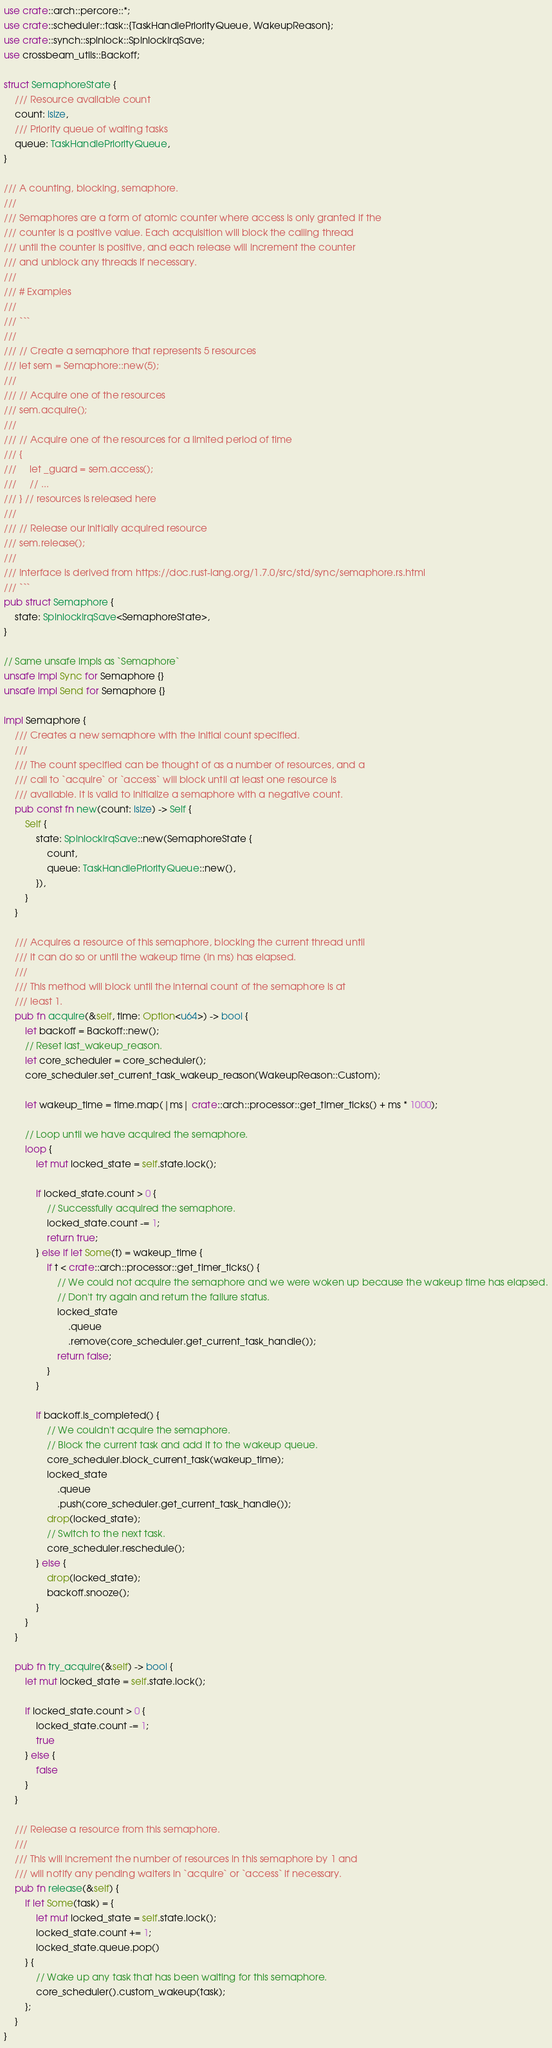<code> <loc_0><loc_0><loc_500><loc_500><_Rust_>use crate::arch::percore::*;
use crate::scheduler::task::{TaskHandlePriorityQueue, WakeupReason};
use crate::synch::spinlock::SpinlockIrqSave;
use crossbeam_utils::Backoff;

struct SemaphoreState {
	/// Resource available count
	count: isize,
	/// Priority queue of waiting tasks
	queue: TaskHandlePriorityQueue,
}

/// A counting, blocking, semaphore.
///
/// Semaphores are a form of atomic counter where access is only granted if the
/// counter is a positive value. Each acquisition will block the calling thread
/// until the counter is positive, and each release will increment the counter
/// and unblock any threads if necessary.
///
/// # Examples
///
/// ```
///
/// // Create a semaphore that represents 5 resources
/// let sem = Semaphore::new(5);
///
/// // Acquire one of the resources
/// sem.acquire();
///
/// // Acquire one of the resources for a limited period of time
/// {
///     let _guard = sem.access();
///     // ...
/// } // resources is released here
///
/// // Release our initially acquired resource
/// sem.release();
///
/// Interface is derived from https://doc.rust-lang.org/1.7.0/src/std/sync/semaphore.rs.html
/// ```
pub struct Semaphore {
	state: SpinlockIrqSave<SemaphoreState>,
}

// Same unsafe impls as `Semaphore`
unsafe impl Sync for Semaphore {}
unsafe impl Send for Semaphore {}

impl Semaphore {
	/// Creates a new semaphore with the initial count specified.
	///
	/// The count specified can be thought of as a number of resources, and a
	/// call to `acquire` or `access` will block until at least one resource is
	/// available. It is valid to initialize a semaphore with a negative count.
	pub const fn new(count: isize) -> Self {
		Self {
			state: SpinlockIrqSave::new(SemaphoreState {
				count,
				queue: TaskHandlePriorityQueue::new(),
			}),
		}
	}

	/// Acquires a resource of this semaphore, blocking the current thread until
	/// it can do so or until the wakeup time (in ms) has elapsed.
	///
	/// This method will block until the internal count of the semaphore is at
	/// least 1.
	pub fn acquire(&self, time: Option<u64>) -> bool {
		let backoff = Backoff::new();
		// Reset last_wakeup_reason.
		let core_scheduler = core_scheduler();
		core_scheduler.set_current_task_wakeup_reason(WakeupReason::Custom);

		let wakeup_time = time.map(|ms| crate::arch::processor::get_timer_ticks() + ms * 1000);

		// Loop until we have acquired the semaphore.
		loop {
			let mut locked_state = self.state.lock();

			if locked_state.count > 0 {
				// Successfully acquired the semaphore.
				locked_state.count -= 1;
				return true;
			} else if let Some(t) = wakeup_time {
				if t < crate::arch::processor::get_timer_ticks() {
					// We could not acquire the semaphore and we were woken up because the wakeup time has elapsed.
					// Don't try again and return the failure status.
					locked_state
						.queue
						.remove(core_scheduler.get_current_task_handle());
					return false;
				}
			}

			if backoff.is_completed() {
				// We couldn't acquire the semaphore.
				// Block the current task and add it to the wakeup queue.
				core_scheduler.block_current_task(wakeup_time);
				locked_state
					.queue
					.push(core_scheduler.get_current_task_handle());
				drop(locked_state);
				// Switch to the next task.
				core_scheduler.reschedule();
			} else {
				drop(locked_state);
				backoff.snooze();
			}
		}
	}

	pub fn try_acquire(&self) -> bool {
		let mut locked_state = self.state.lock();

		if locked_state.count > 0 {
			locked_state.count -= 1;
			true
		} else {
			false
		}
	}

	/// Release a resource from this semaphore.
	///
	/// This will increment the number of resources in this semaphore by 1 and
	/// will notify any pending waiters in `acquire` or `access` if necessary.
	pub fn release(&self) {
		if let Some(task) = {
			let mut locked_state = self.state.lock();
			locked_state.count += 1;
			locked_state.queue.pop()
		} {
			// Wake up any task that has been waiting for this semaphore.
			core_scheduler().custom_wakeup(task);
		};
	}
}
</code> 